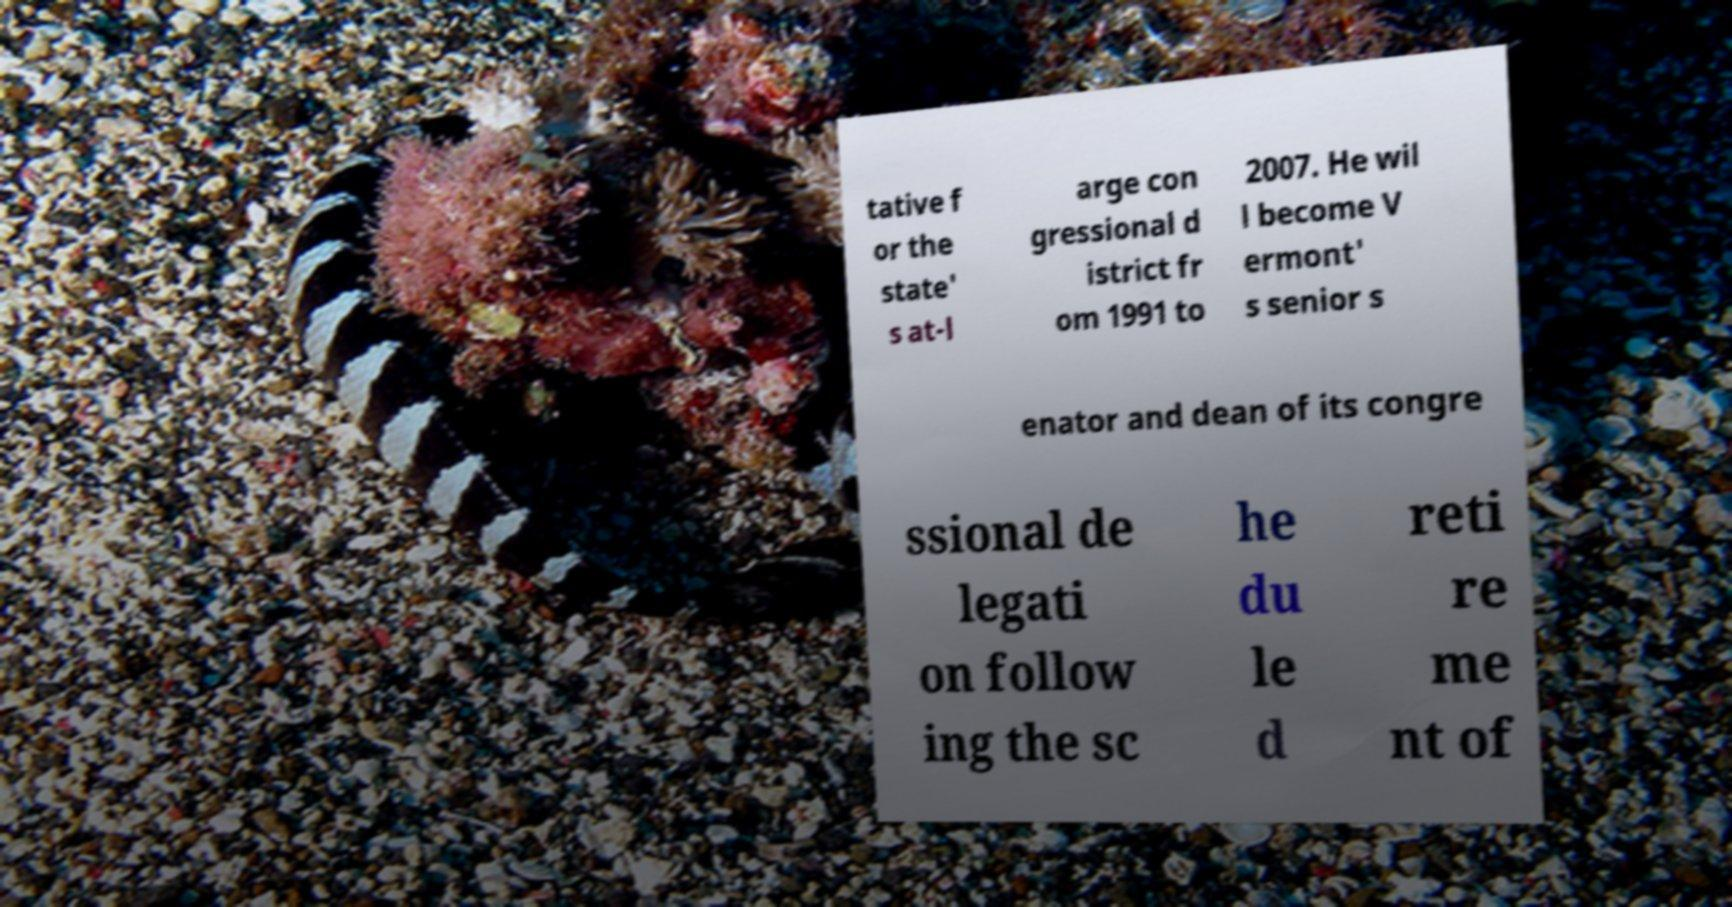Could you assist in decoding the text presented in this image and type it out clearly? tative f or the state' s at-l arge con gressional d istrict fr om 1991 to 2007. He wil l become V ermont' s senior s enator and dean of its congre ssional de legati on follow ing the sc he du le d reti re me nt of 